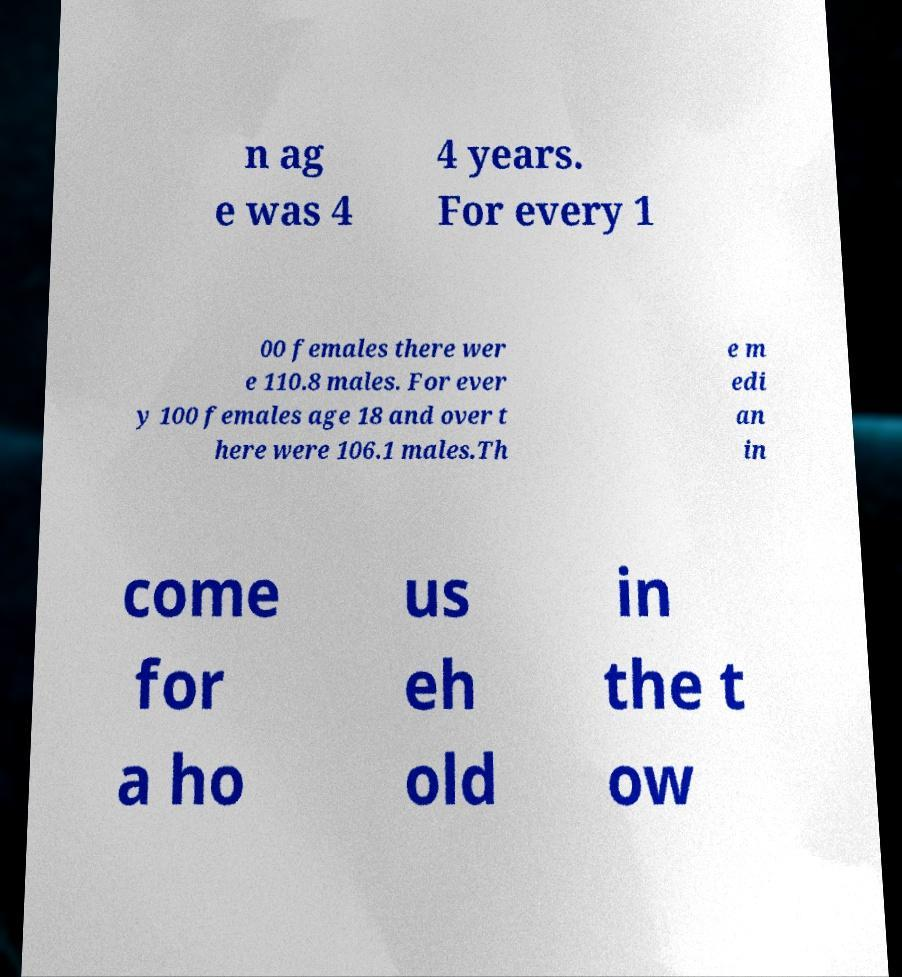I need the written content from this picture converted into text. Can you do that? n ag e was 4 4 years. For every 1 00 females there wer e 110.8 males. For ever y 100 females age 18 and over t here were 106.1 males.Th e m edi an in come for a ho us eh old in the t ow 